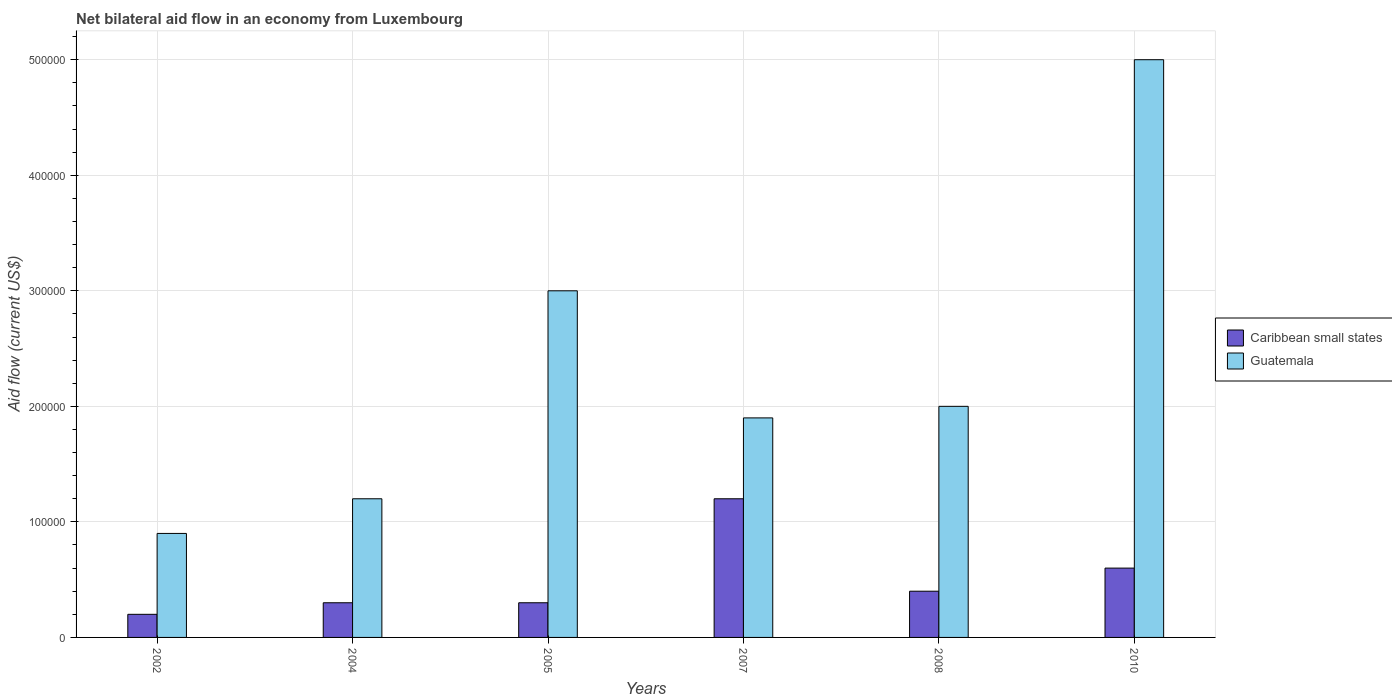How many groups of bars are there?
Your answer should be very brief. 6. How many bars are there on the 1st tick from the right?
Provide a succinct answer. 2. What is the label of the 5th group of bars from the left?
Your response must be concise. 2008. In how many cases, is the number of bars for a given year not equal to the number of legend labels?
Make the answer very short. 0. What is the net bilateral aid flow in Guatemala in 2008?
Your response must be concise. 2.00e+05. Across all years, what is the maximum net bilateral aid flow in Caribbean small states?
Give a very brief answer. 1.20e+05. In which year was the net bilateral aid flow in Guatemala maximum?
Your answer should be very brief. 2010. What is the total net bilateral aid flow in Guatemala in the graph?
Make the answer very short. 1.40e+06. What is the difference between the net bilateral aid flow in Guatemala in 2008 and that in 2010?
Give a very brief answer. -3.00e+05. What is the difference between the net bilateral aid flow in Guatemala in 2005 and the net bilateral aid flow in Caribbean small states in 2004?
Provide a short and direct response. 2.70e+05. What is the average net bilateral aid flow in Caribbean small states per year?
Ensure brevity in your answer.  5.00e+04. What is the difference between the highest and the lowest net bilateral aid flow in Caribbean small states?
Your response must be concise. 1.00e+05. What does the 1st bar from the left in 2008 represents?
Make the answer very short. Caribbean small states. What does the 1st bar from the right in 2004 represents?
Give a very brief answer. Guatemala. How many bars are there?
Offer a very short reply. 12. Does the graph contain grids?
Offer a very short reply. Yes. What is the title of the graph?
Your answer should be compact. Net bilateral aid flow in an economy from Luxembourg. Does "Brunei Darussalam" appear as one of the legend labels in the graph?
Provide a short and direct response. No. What is the label or title of the X-axis?
Offer a very short reply. Years. What is the Aid flow (current US$) in Guatemala in 2002?
Offer a very short reply. 9.00e+04. What is the Aid flow (current US$) of Caribbean small states in 2004?
Offer a terse response. 3.00e+04. What is the Aid flow (current US$) in Guatemala in 2004?
Your answer should be very brief. 1.20e+05. What is the Aid flow (current US$) in Caribbean small states in 2005?
Give a very brief answer. 3.00e+04. What is the Aid flow (current US$) in Guatemala in 2005?
Offer a terse response. 3.00e+05. What is the Aid flow (current US$) of Guatemala in 2007?
Make the answer very short. 1.90e+05. What is the Aid flow (current US$) of Caribbean small states in 2008?
Make the answer very short. 4.00e+04. What is the Aid flow (current US$) in Guatemala in 2008?
Ensure brevity in your answer.  2.00e+05. What is the Aid flow (current US$) of Guatemala in 2010?
Provide a succinct answer. 5.00e+05. Across all years, what is the maximum Aid flow (current US$) in Guatemala?
Keep it short and to the point. 5.00e+05. What is the total Aid flow (current US$) in Caribbean small states in the graph?
Your answer should be compact. 3.00e+05. What is the total Aid flow (current US$) of Guatemala in the graph?
Your response must be concise. 1.40e+06. What is the difference between the Aid flow (current US$) of Caribbean small states in 2002 and that in 2004?
Offer a very short reply. -10000. What is the difference between the Aid flow (current US$) in Caribbean small states in 2002 and that in 2005?
Ensure brevity in your answer.  -10000. What is the difference between the Aid flow (current US$) in Guatemala in 2002 and that in 2007?
Your answer should be compact. -1.00e+05. What is the difference between the Aid flow (current US$) of Caribbean small states in 2002 and that in 2008?
Your response must be concise. -2.00e+04. What is the difference between the Aid flow (current US$) in Guatemala in 2002 and that in 2010?
Your answer should be compact. -4.10e+05. What is the difference between the Aid flow (current US$) in Caribbean small states in 2004 and that in 2005?
Your answer should be compact. 0. What is the difference between the Aid flow (current US$) of Caribbean small states in 2004 and that in 2008?
Offer a terse response. -10000. What is the difference between the Aid flow (current US$) in Guatemala in 2004 and that in 2008?
Keep it short and to the point. -8.00e+04. What is the difference between the Aid flow (current US$) in Caribbean small states in 2004 and that in 2010?
Your answer should be compact. -3.00e+04. What is the difference between the Aid flow (current US$) of Guatemala in 2004 and that in 2010?
Your answer should be very brief. -3.80e+05. What is the difference between the Aid flow (current US$) in Guatemala in 2005 and that in 2007?
Offer a very short reply. 1.10e+05. What is the difference between the Aid flow (current US$) in Caribbean small states in 2007 and that in 2008?
Your answer should be compact. 8.00e+04. What is the difference between the Aid flow (current US$) of Guatemala in 2007 and that in 2008?
Your answer should be very brief. -10000. What is the difference between the Aid flow (current US$) of Guatemala in 2007 and that in 2010?
Offer a very short reply. -3.10e+05. What is the difference between the Aid flow (current US$) in Guatemala in 2008 and that in 2010?
Your answer should be compact. -3.00e+05. What is the difference between the Aid flow (current US$) of Caribbean small states in 2002 and the Aid flow (current US$) of Guatemala in 2004?
Offer a terse response. -1.00e+05. What is the difference between the Aid flow (current US$) in Caribbean small states in 2002 and the Aid flow (current US$) in Guatemala in 2005?
Keep it short and to the point. -2.80e+05. What is the difference between the Aid flow (current US$) of Caribbean small states in 2002 and the Aid flow (current US$) of Guatemala in 2007?
Your answer should be compact. -1.70e+05. What is the difference between the Aid flow (current US$) in Caribbean small states in 2002 and the Aid flow (current US$) in Guatemala in 2010?
Your answer should be compact. -4.80e+05. What is the difference between the Aid flow (current US$) of Caribbean small states in 2004 and the Aid flow (current US$) of Guatemala in 2005?
Provide a succinct answer. -2.70e+05. What is the difference between the Aid flow (current US$) of Caribbean small states in 2004 and the Aid flow (current US$) of Guatemala in 2007?
Your response must be concise. -1.60e+05. What is the difference between the Aid flow (current US$) of Caribbean small states in 2004 and the Aid flow (current US$) of Guatemala in 2008?
Your answer should be compact. -1.70e+05. What is the difference between the Aid flow (current US$) of Caribbean small states in 2004 and the Aid flow (current US$) of Guatemala in 2010?
Your answer should be very brief. -4.70e+05. What is the difference between the Aid flow (current US$) of Caribbean small states in 2005 and the Aid flow (current US$) of Guatemala in 2007?
Keep it short and to the point. -1.60e+05. What is the difference between the Aid flow (current US$) in Caribbean small states in 2005 and the Aid flow (current US$) in Guatemala in 2008?
Provide a succinct answer. -1.70e+05. What is the difference between the Aid flow (current US$) of Caribbean small states in 2005 and the Aid flow (current US$) of Guatemala in 2010?
Your answer should be compact. -4.70e+05. What is the difference between the Aid flow (current US$) in Caribbean small states in 2007 and the Aid flow (current US$) in Guatemala in 2010?
Ensure brevity in your answer.  -3.80e+05. What is the difference between the Aid flow (current US$) in Caribbean small states in 2008 and the Aid flow (current US$) in Guatemala in 2010?
Provide a succinct answer. -4.60e+05. What is the average Aid flow (current US$) of Caribbean small states per year?
Offer a terse response. 5.00e+04. What is the average Aid flow (current US$) of Guatemala per year?
Provide a succinct answer. 2.33e+05. In the year 2005, what is the difference between the Aid flow (current US$) of Caribbean small states and Aid flow (current US$) of Guatemala?
Offer a very short reply. -2.70e+05. In the year 2008, what is the difference between the Aid flow (current US$) in Caribbean small states and Aid flow (current US$) in Guatemala?
Your response must be concise. -1.60e+05. In the year 2010, what is the difference between the Aid flow (current US$) in Caribbean small states and Aid flow (current US$) in Guatemala?
Give a very brief answer. -4.40e+05. What is the ratio of the Aid flow (current US$) in Caribbean small states in 2002 to that in 2004?
Provide a succinct answer. 0.67. What is the ratio of the Aid flow (current US$) of Guatemala in 2002 to that in 2004?
Offer a terse response. 0.75. What is the ratio of the Aid flow (current US$) of Caribbean small states in 2002 to that in 2005?
Provide a short and direct response. 0.67. What is the ratio of the Aid flow (current US$) in Guatemala in 2002 to that in 2007?
Offer a very short reply. 0.47. What is the ratio of the Aid flow (current US$) of Caribbean small states in 2002 to that in 2008?
Offer a very short reply. 0.5. What is the ratio of the Aid flow (current US$) of Guatemala in 2002 to that in 2008?
Your response must be concise. 0.45. What is the ratio of the Aid flow (current US$) in Guatemala in 2002 to that in 2010?
Keep it short and to the point. 0.18. What is the ratio of the Aid flow (current US$) in Caribbean small states in 2004 to that in 2005?
Your response must be concise. 1. What is the ratio of the Aid flow (current US$) in Caribbean small states in 2004 to that in 2007?
Your response must be concise. 0.25. What is the ratio of the Aid flow (current US$) in Guatemala in 2004 to that in 2007?
Offer a very short reply. 0.63. What is the ratio of the Aid flow (current US$) of Caribbean small states in 2004 to that in 2010?
Keep it short and to the point. 0.5. What is the ratio of the Aid flow (current US$) in Guatemala in 2004 to that in 2010?
Your answer should be very brief. 0.24. What is the ratio of the Aid flow (current US$) of Caribbean small states in 2005 to that in 2007?
Ensure brevity in your answer.  0.25. What is the ratio of the Aid flow (current US$) in Guatemala in 2005 to that in 2007?
Give a very brief answer. 1.58. What is the ratio of the Aid flow (current US$) in Caribbean small states in 2005 to that in 2010?
Ensure brevity in your answer.  0.5. What is the ratio of the Aid flow (current US$) in Caribbean small states in 2007 to that in 2008?
Your response must be concise. 3. What is the ratio of the Aid flow (current US$) of Guatemala in 2007 to that in 2010?
Your answer should be compact. 0.38. What is the ratio of the Aid flow (current US$) in Guatemala in 2008 to that in 2010?
Keep it short and to the point. 0.4. What is the difference between the highest and the lowest Aid flow (current US$) in Caribbean small states?
Offer a terse response. 1.00e+05. 